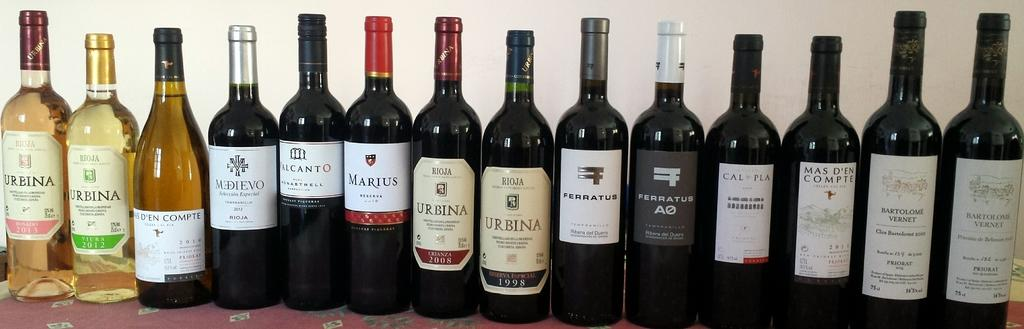<image>
Share a concise interpretation of the image provided. Two bottles of Urbina wine sit among other bottles in a row. 